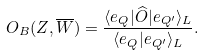<formula> <loc_0><loc_0><loc_500><loc_500>O _ { B } ( Z , \overline { W } ) = \frac { \langle e _ { Q } | \widehat { O } | e _ { Q ^ { \prime } } \rangle _ { L } } { \langle e _ { Q } | e _ { Q ^ { \prime } } \rangle _ { L } } .</formula> 